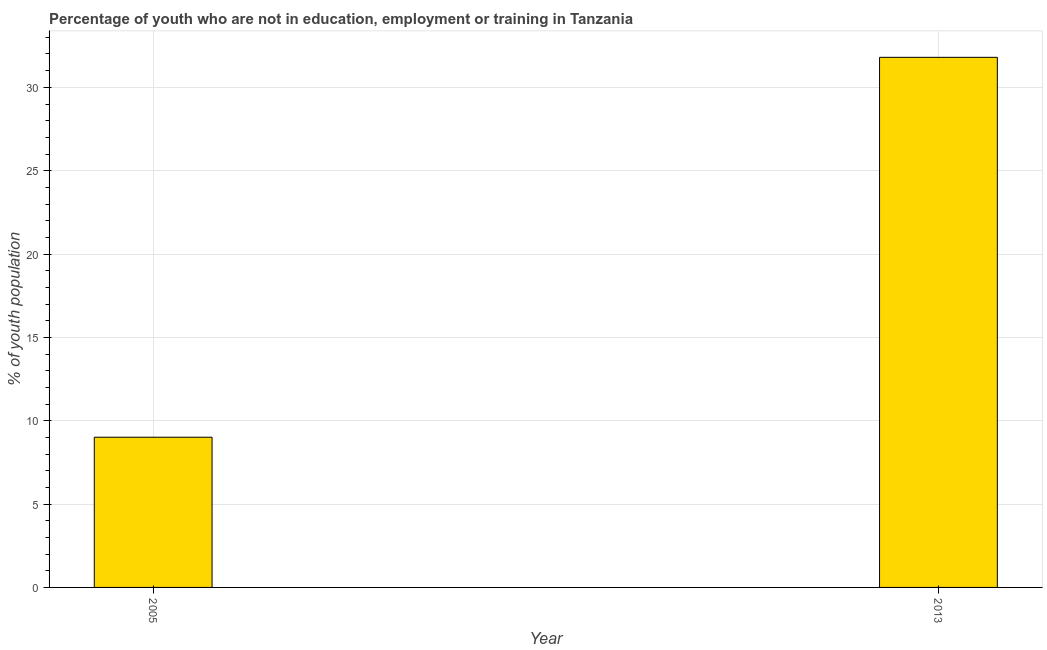Does the graph contain any zero values?
Offer a very short reply. No. Does the graph contain grids?
Your response must be concise. Yes. What is the title of the graph?
Give a very brief answer. Percentage of youth who are not in education, employment or training in Tanzania. What is the label or title of the X-axis?
Offer a very short reply. Year. What is the label or title of the Y-axis?
Provide a short and direct response. % of youth population. What is the unemployed youth population in 2005?
Give a very brief answer. 9.01. Across all years, what is the maximum unemployed youth population?
Your answer should be very brief. 31.8. Across all years, what is the minimum unemployed youth population?
Ensure brevity in your answer.  9.01. In which year was the unemployed youth population minimum?
Make the answer very short. 2005. What is the sum of the unemployed youth population?
Give a very brief answer. 40.81. What is the difference between the unemployed youth population in 2005 and 2013?
Ensure brevity in your answer.  -22.79. What is the average unemployed youth population per year?
Provide a succinct answer. 20.41. What is the median unemployed youth population?
Provide a short and direct response. 20.4. In how many years, is the unemployed youth population greater than 21 %?
Your response must be concise. 1. Do a majority of the years between 2013 and 2005 (inclusive) have unemployed youth population greater than 15 %?
Offer a terse response. No. What is the ratio of the unemployed youth population in 2005 to that in 2013?
Provide a succinct answer. 0.28. Are all the bars in the graph horizontal?
Provide a short and direct response. No. How many years are there in the graph?
Ensure brevity in your answer.  2. What is the difference between two consecutive major ticks on the Y-axis?
Offer a terse response. 5. What is the % of youth population of 2005?
Your answer should be very brief. 9.01. What is the % of youth population in 2013?
Your answer should be compact. 31.8. What is the difference between the % of youth population in 2005 and 2013?
Your answer should be compact. -22.79. What is the ratio of the % of youth population in 2005 to that in 2013?
Your response must be concise. 0.28. 